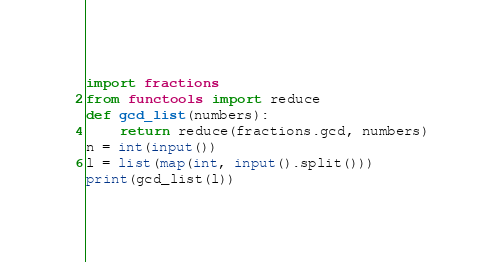Convert code to text. <code><loc_0><loc_0><loc_500><loc_500><_Python_>import fractions
from functools import reduce
def gcd_list(numbers):
    return reduce(fractions.gcd, numbers)
n = int(input())
l = list(map(int, input().split()))
print(gcd_list(l))</code> 